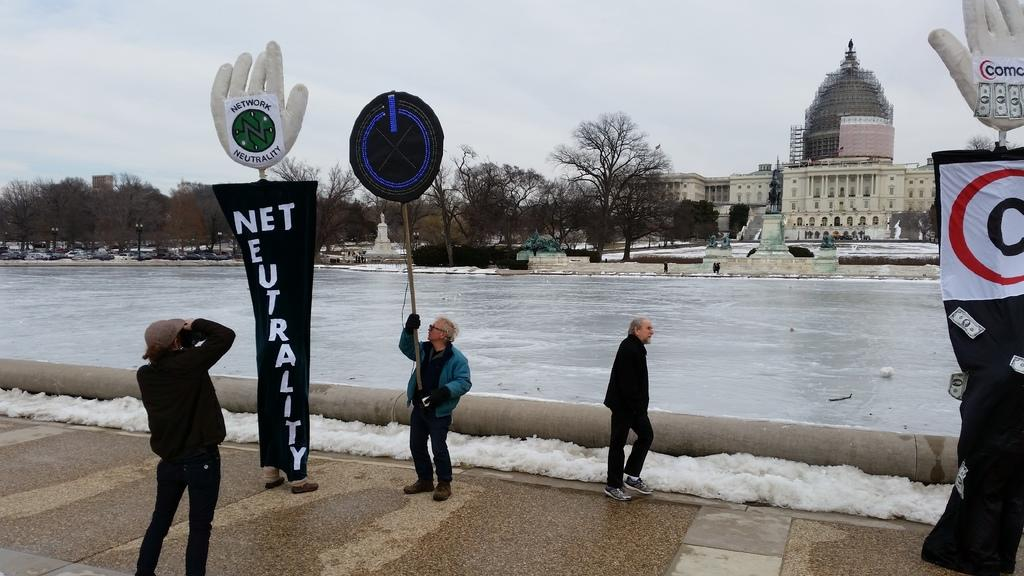<image>
Describe the image concisely. a poster that says Net Neutrality on it 